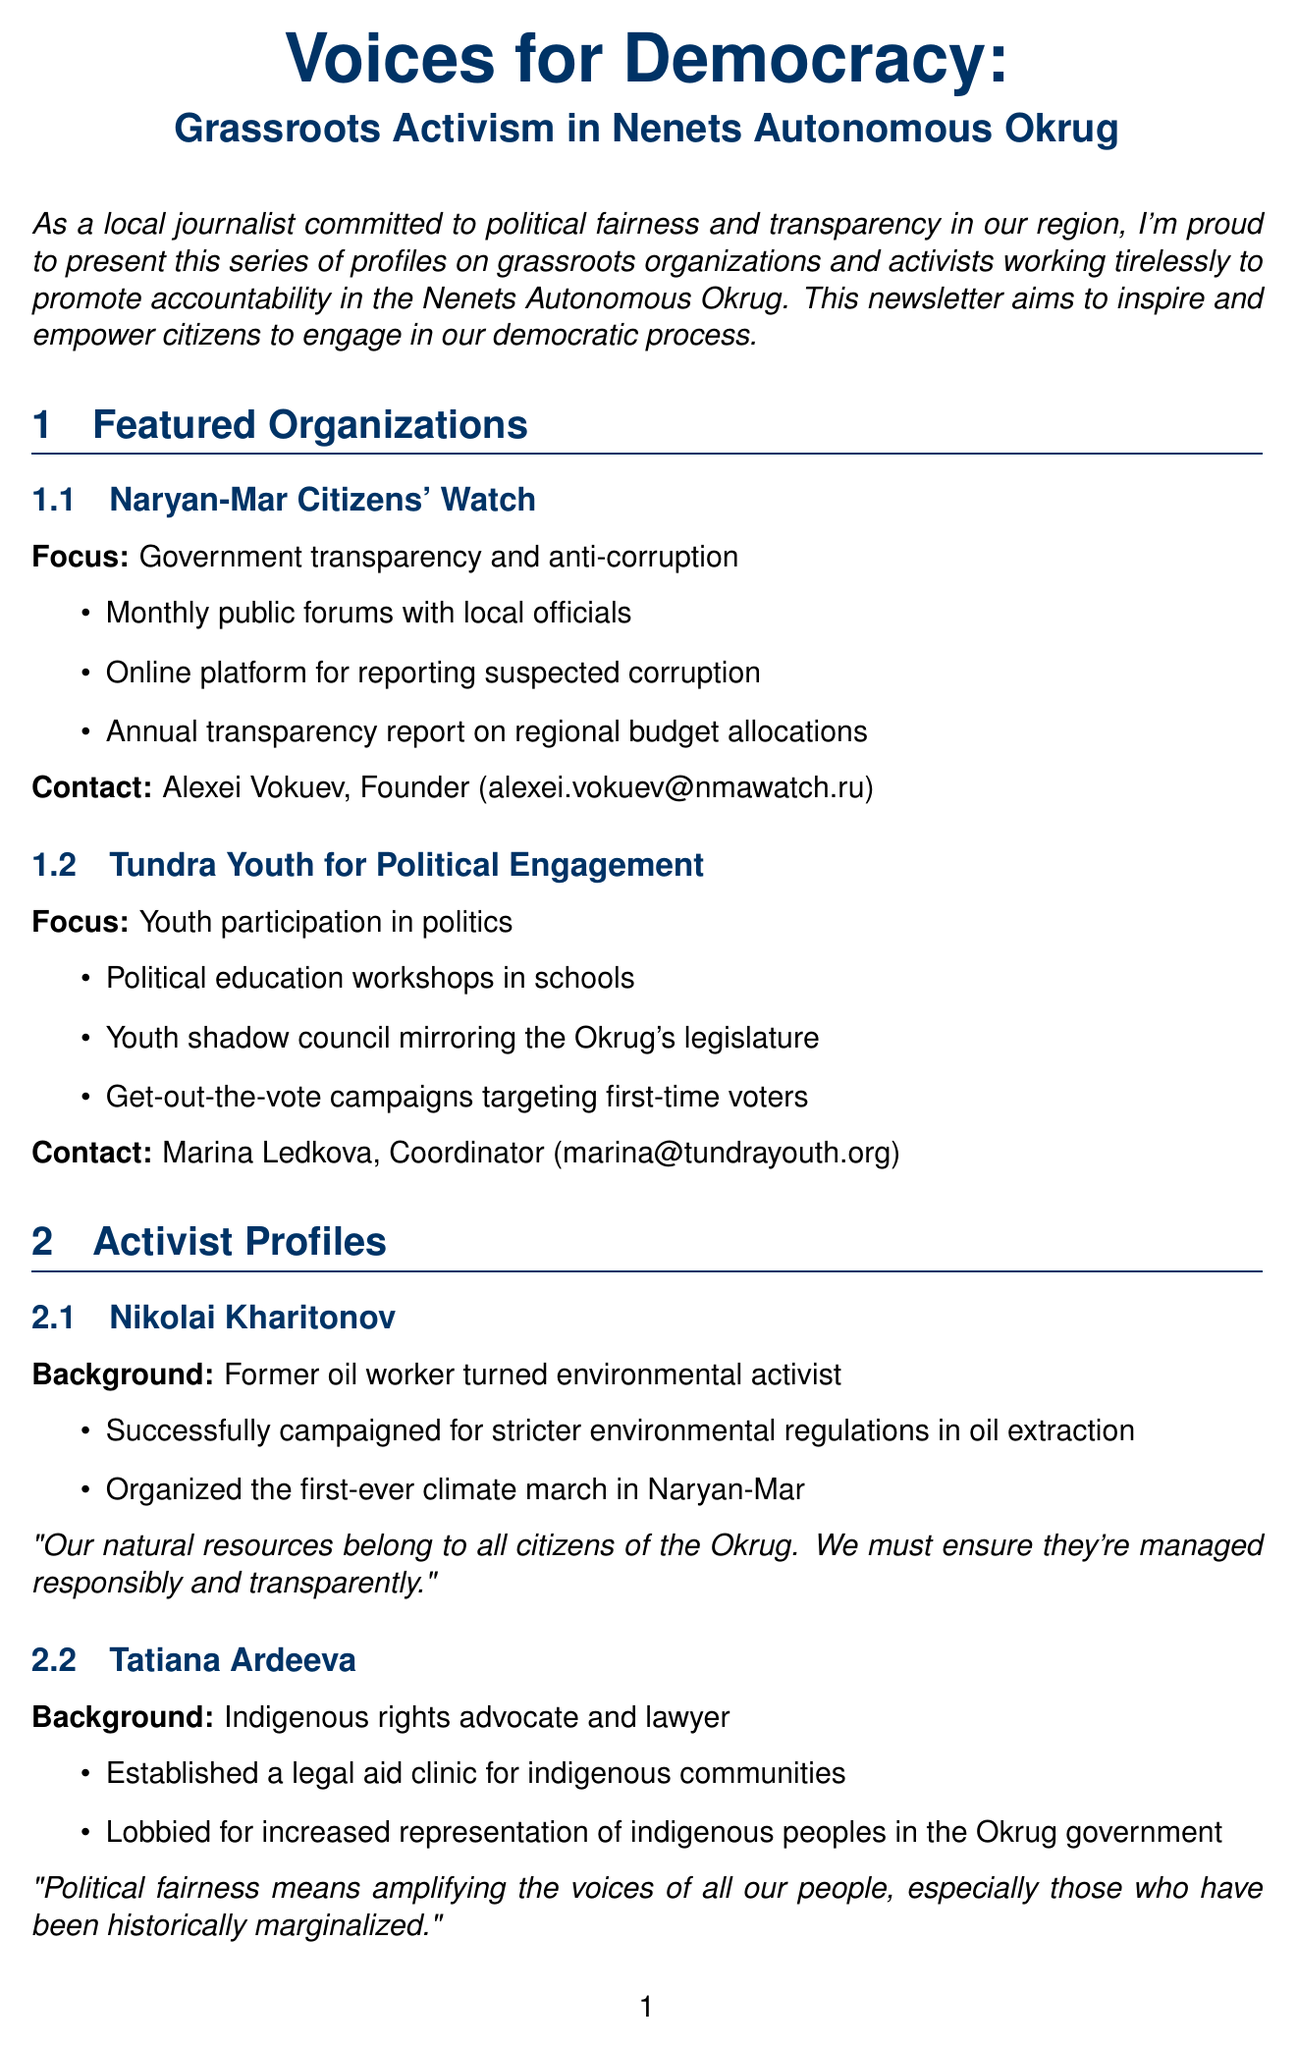What is the title of the newsletter? The title of the newsletter is prominently displayed at the beginning of the document.
Answer: Voices for Democracy: Grassroots Activism in Nenets Autonomous Okrug Who is the founder of Naryan-Mar Citizens' Watch? The document mentions the contact person for the organization, which indicates their position.
Answer: Alexei Vokuev What initiative does Tundra Youth for Political Engagement focus on? The document highlights different focuses for the organizations, including this one.
Answer: Youth participation in politics When is the Nenets Autonomous Okrug Civic Forum scheduled? The date for the next event is listed under the upcoming events section.
Answer: September 15-16, 2023 What is a suggested action for attending local government meetings? The document provides specific action items for citizen engagement tips, including marking the calendar.
Answer: Mark your calendar for the next meeting on [DATE] at the Naryan-Mar City Hall How many key initiatives does Naryan-Mar Citizens' Watch have listed? The document provides a list of initiatives, which can be counted.
Answer: Three What defines political fairness according to Tatiana Ardeeva? The quote attributed to Tatiana Ardeeva explains her perspective on political fairness.
Answer: Amplifying the voices of all our people What type of workshop is hosted by Naryan-Mar Citizens' Watch? The document specifies the focus of this workshop listed in the upcoming events section.
Answer: Transparency in Resource Management Workshop 